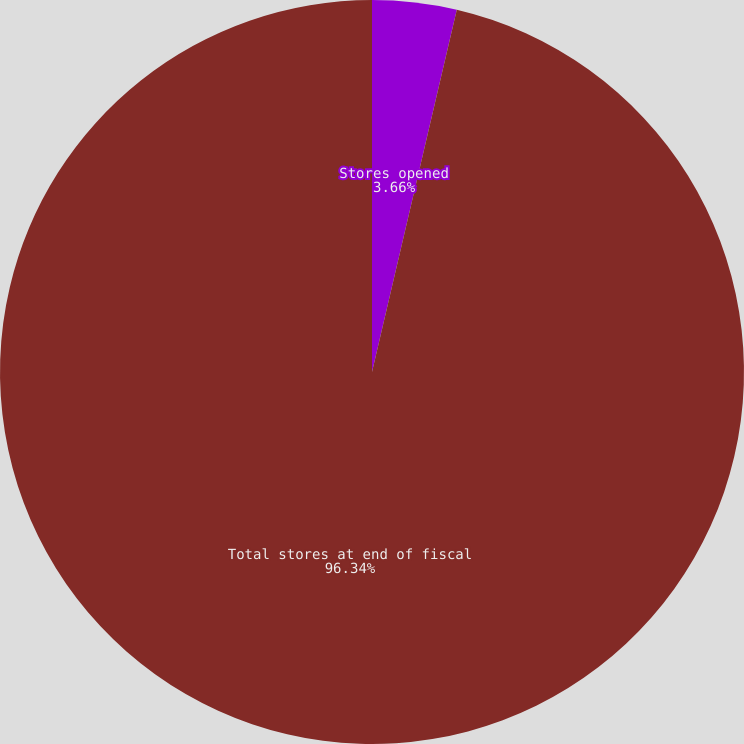<chart> <loc_0><loc_0><loc_500><loc_500><pie_chart><fcel>Stores opened<fcel>Total stores at end of fiscal<nl><fcel>3.66%<fcel>96.34%<nl></chart> 